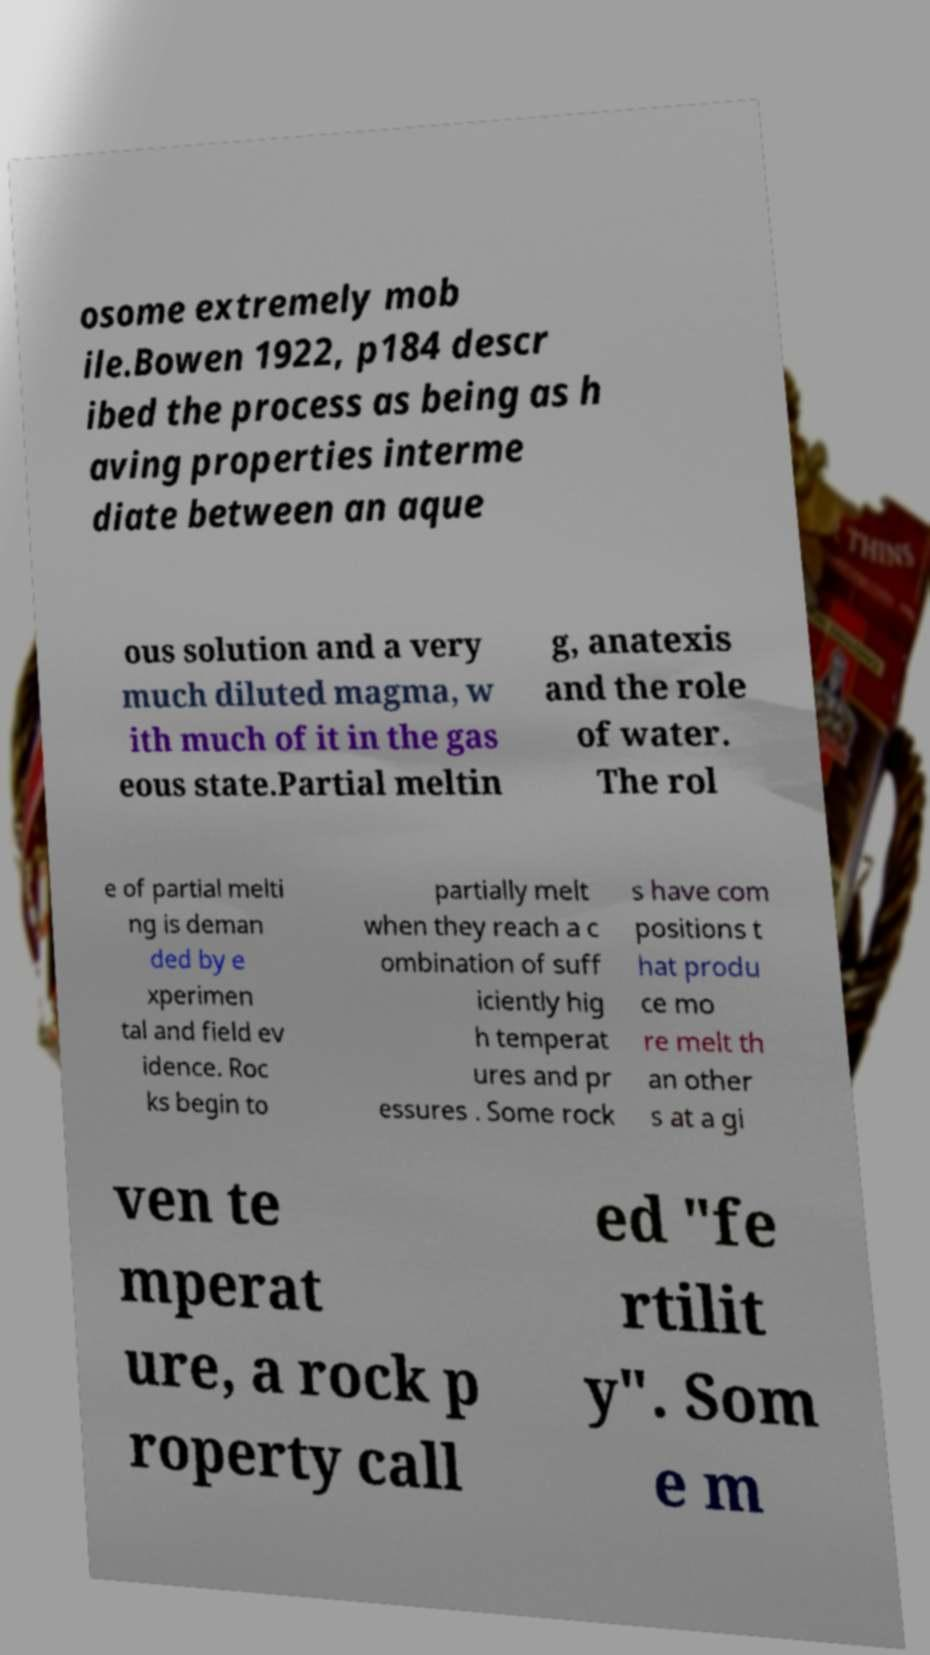I need the written content from this picture converted into text. Can you do that? osome extremely mob ile.Bowen 1922, p184 descr ibed the process as being as h aving properties interme diate between an aque ous solution and a very much diluted magma, w ith much of it in the gas eous state.Partial meltin g, anatexis and the role of water. The rol e of partial melti ng is deman ded by e xperimen tal and field ev idence. Roc ks begin to partially melt when they reach a c ombination of suff iciently hig h temperat ures and pr essures . Some rock s have com positions t hat produ ce mo re melt th an other s at a gi ven te mperat ure, a rock p roperty call ed "fe rtilit y". Som e m 